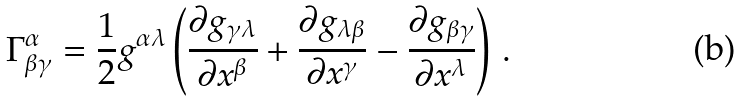<formula> <loc_0><loc_0><loc_500><loc_500>\Gamma ^ { \alpha } _ { \beta \gamma } = \frac { 1 } { 2 } g ^ { \alpha \lambda } \left ( \frac { \partial g _ { \gamma \lambda } } { \partial x ^ { \beta } } + \frac { \partial g _ { \lambda \beta } } { \partial x ^ { \gamma } } - \frac { \partial g _ { \beta \gamma } } { \partial x ^ { \lambda } } \right ) \, .</formula> 